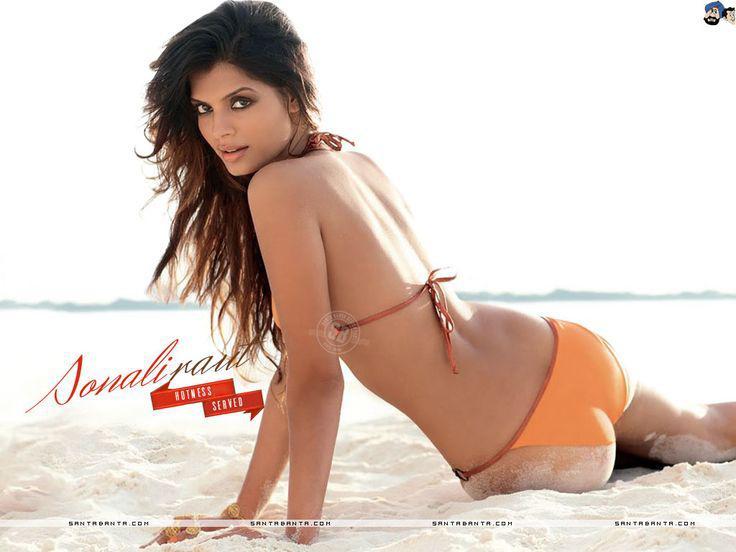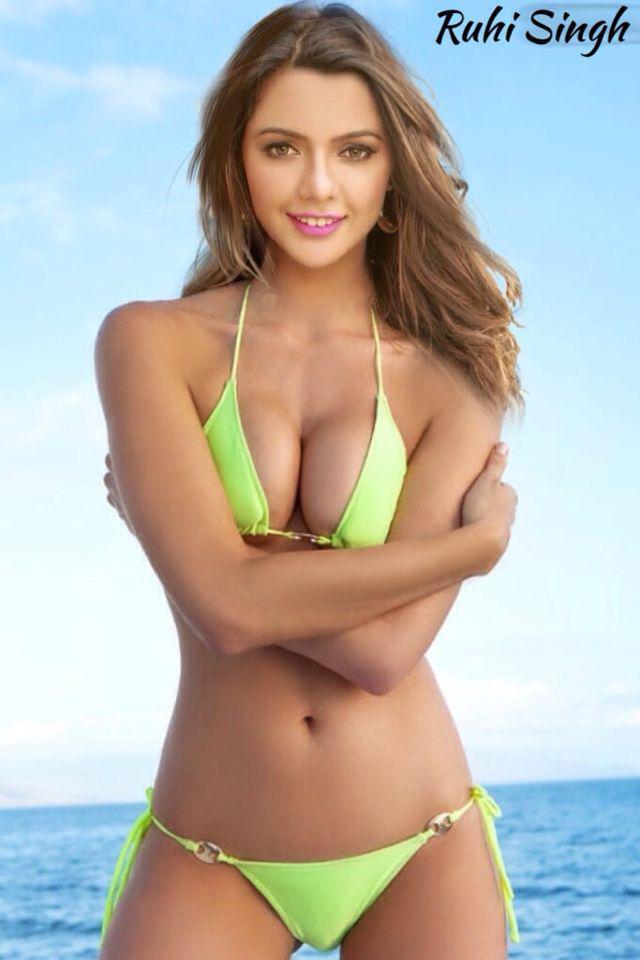The first image is the image on the left, the second image is the image on the right. Given the left and right images, does the statement "Each of the images contains exactly one model." hold true? Answer yes or no. Yes. 